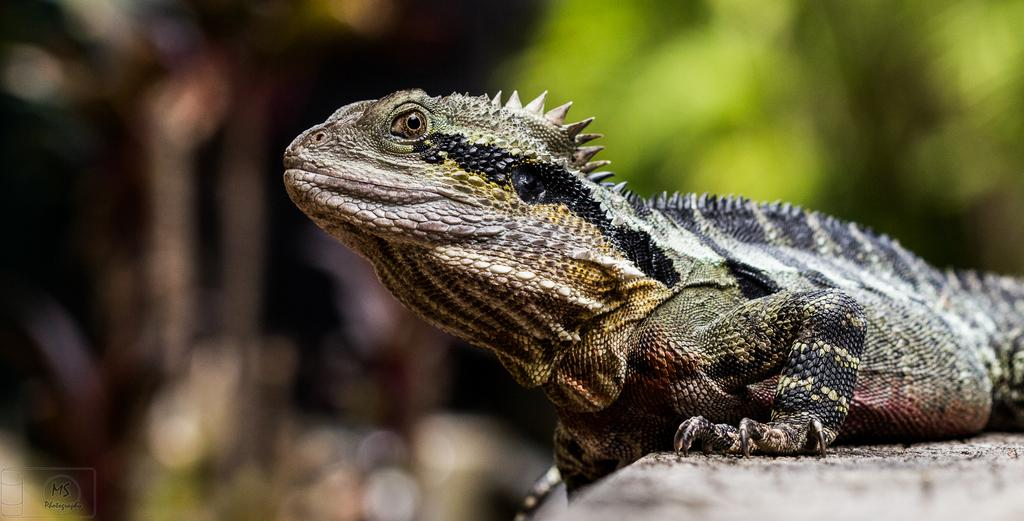What is the main subject of the image? There is a garden lizard in the center of the image. Can you describe the appearance of the garden lizard? The garden lizard is the main subject, and its appearance is not described in the provided facts. What is the surrounding environment of the garden lizard? The surrounding environment is not described in the provided facts. What type of basket is hanging from the tree in the image? There is no mention of a basket or tree in the provided facts, so we cannot answer this question. 